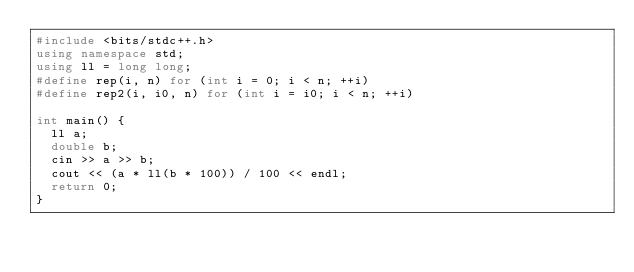<code> <loc_0><loc_0><loc_500><loc_500><_C++_>#include <bits/stdc++.h>
using namespace std;
using ll = long long;
#define rep(i, n) for (int i = 0; i < n; ++i)
#define rep2(i, i0, n) for (int i = i0; i < n; ++i)

int main() {
  ll a;
  double b;
  cin >> a >> b;
  cout << (a * ll(b * 100)) / 100 << endl;
  return 0;
}</code> 